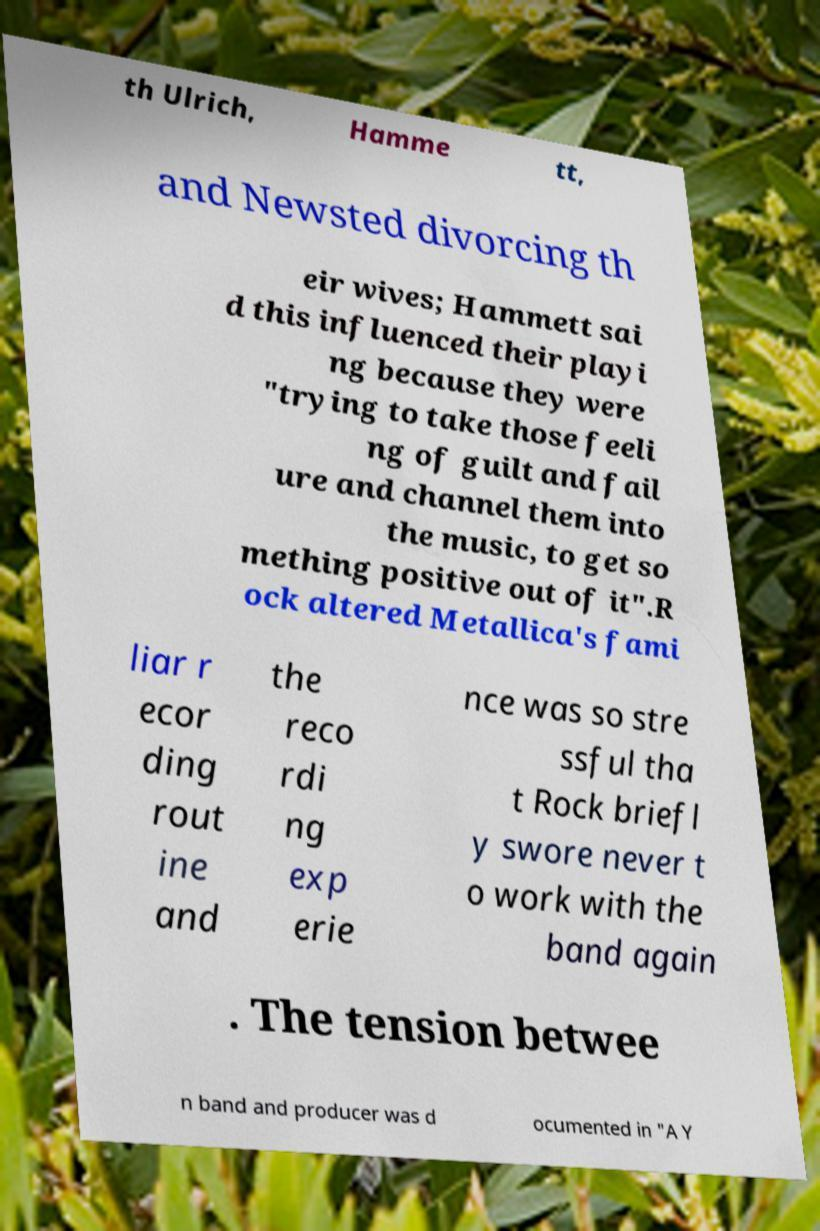Could you assist in decoding the text presented in this image and type it out clearly? th Ulrich, Hamme tt, and Newsted divorcing th eir wives; Hammett sai d this influenced their playi ng because they were "trying to take those feeli ng of guilt and fail ure and channel them into the music, to get so mething positive out of it".R ock altered Metallica's fami liar r ecor ding rout ine and the reco rdi ng exp erie nce was so stre ssful tha t Rock briefl y swore never t o work with the band again . The tension betwee n band and producer was d ocumented in "A Y 